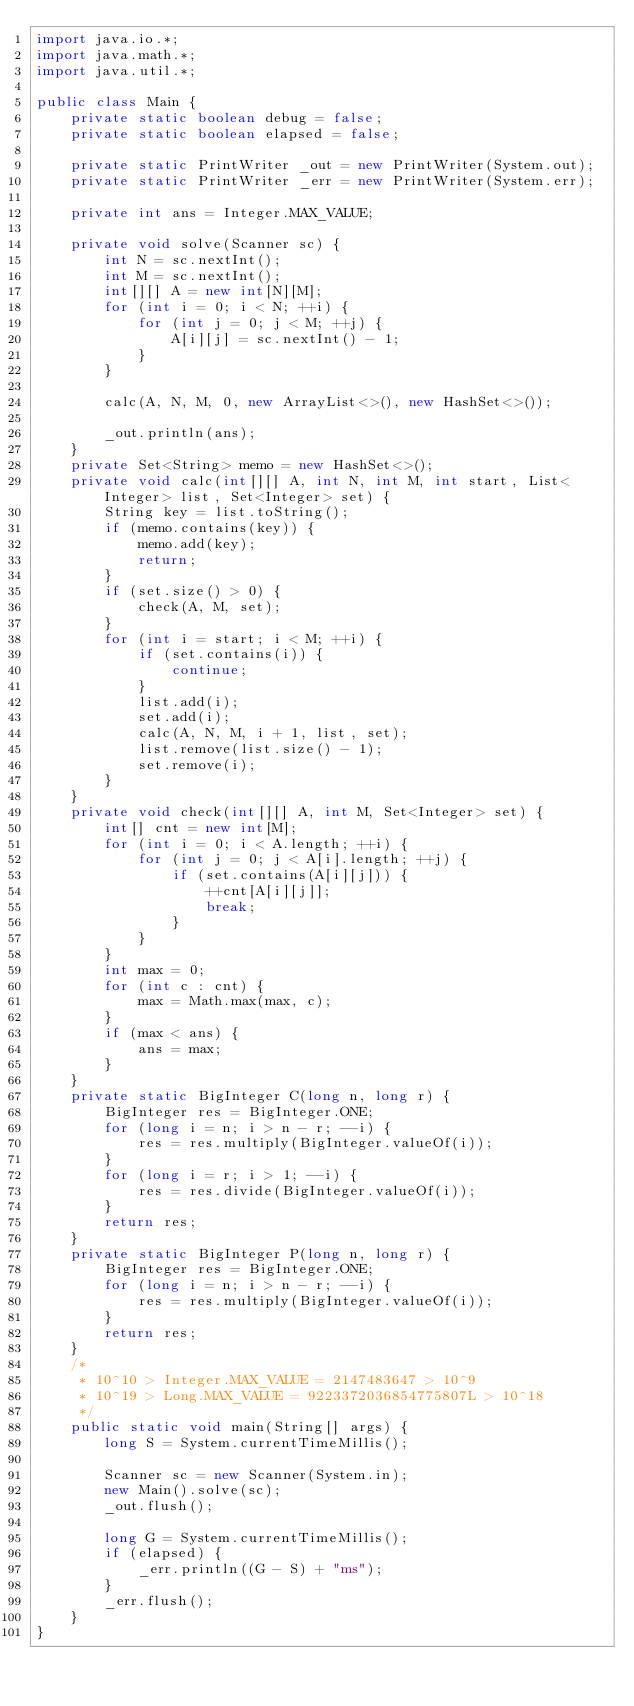Convert code to text. <code><loc_0><loc_0><loc_500><loc_500><_Java_>import java.io.*;
import java.math.*;
import java.util.*;

public class Main {
    private static boolean debug = false;
    private static boolean elapsed = false;

    private static PrintWriter _out = new PrintWriter(System.out);
    private static PrintWriter _err = new PrintWriter(System.err);

    private int ans = Integer.MAX_VALUE;

    private void solve(Scanner sc) {
        int N = sc.nextInt();
        int M = sc.nextInt();
        int[][] A = new int[N][M];
        for (int i = 0; i < N; ++i) {
            for (int j = 0; j < M; ++j) {
                A[i][j] = sc.nextInt() - 1;
            }
        }

        calc(A, N, M, 0, new ArrayList<>(), new HashSet<>());

        _out.println(ans);
    }
    private Set<String> memo = new HashSet<>();
    private void calc(int[][] A, int N, int M, int start, List<Integer> list, Set<Integer> set) {
        String key = list.toString();
        if (memo.contains(key)) {
            memo.add(key);
            return;
        }
        if (set.size() > 0) {
            check(A, M, set);
        }
        for (int i = start; i < M; ++i) {
            if (set.contains(i)) {
                continue;
            }
            list.add(i);
            set.add(i);
            calc(A, N, M, i + 1, list, set);
            list.remove(list.size() - 1);
            set.remove(i);
        }
    }
    private void check(int[][] A, int M, Set<Integer> set) {
        int[] cnt = new int[M];
        for (int i = 0; i < A.length; ++i) {
            for (int j = 0; j < A[i].length; ++j) {
                if (set.contains(A[i][j])) {
                    ++cnt[A[i][j]];
                    break;
                }
            }
        }
        int max = 0;
        for (int c : cnt) {
            max = Math.max(max, c);
        }
        if (max < ans) {
            ans = max;
        }
    }
    private static BigInteger C(long n, long r) {
        BigInteger res = BigInteger.ONE;
        for (long i = n; i > n - r; --i) {
            res = res.multiply(BigInteger.valueOf(i));
        }
        for (long i = r; i > 1; --i) {
            res = res.divide(BigInteger.valueOf(i));
        }
        return res;
    }
    private static BigInteger P(long n, long r) {
        BigInteger res = BigInteger.ONE;
        for (long i = n; i > n - r; --i) {
            res = res.multiply(BigInteger.valueOf(i));
        }
        return res;
    }
    /*
     * 10^10 > Integer.MAX_VALUE = 2147483647 > 10^9
     * 10^19 > Long.MAX_VALUE = 9223372036854775807L > 10^18
     */
    public static void main(String[] args) {
        long S = System.currentTimeMillis();

        Scanner sc = new Scanner(System.in);
        new Main().solve(sc);
        _out.flush();

        long G = System.currentTimeMillis();
        if (elapsed) {
            _err.println((G - S) + "ms");
        }
        _err.flush();
    }
}</code> 